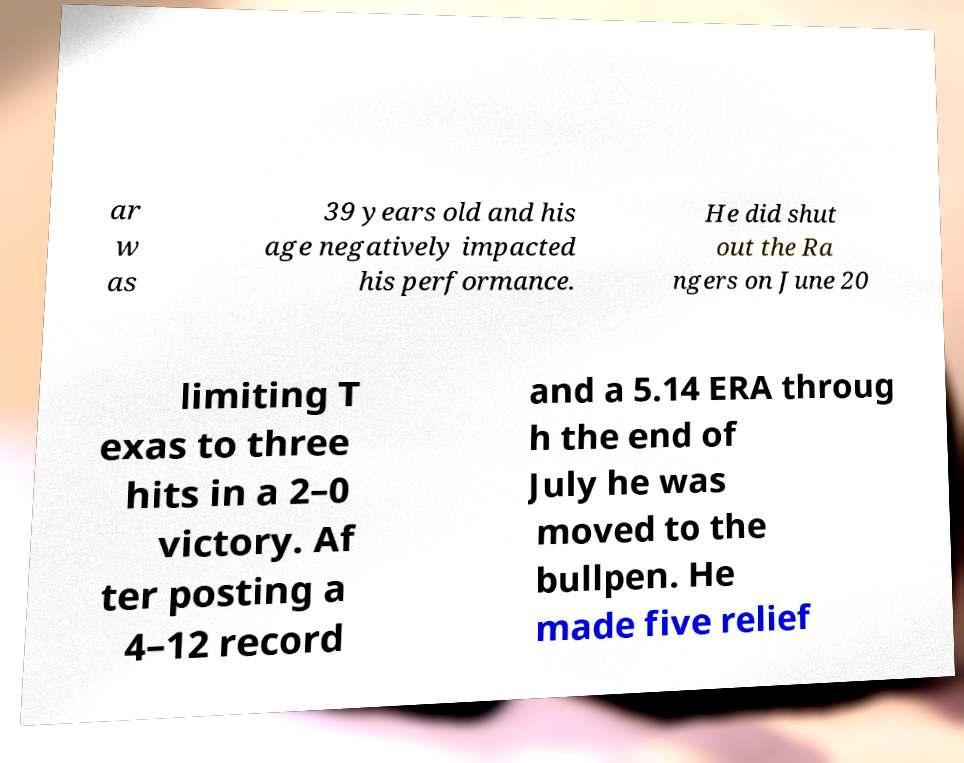I need the written content from this picture converted into text. Can you do that? ar w as 39 years old and his age negatively impacted his performance. He did shut out the Ra ngers on June 20 limiting T exas to three hits in a 2–0 victory. Af ter posting a 4–12 record and a 5.14 ERA throug h the end of July he was moved to the bullpen. He made five relief 